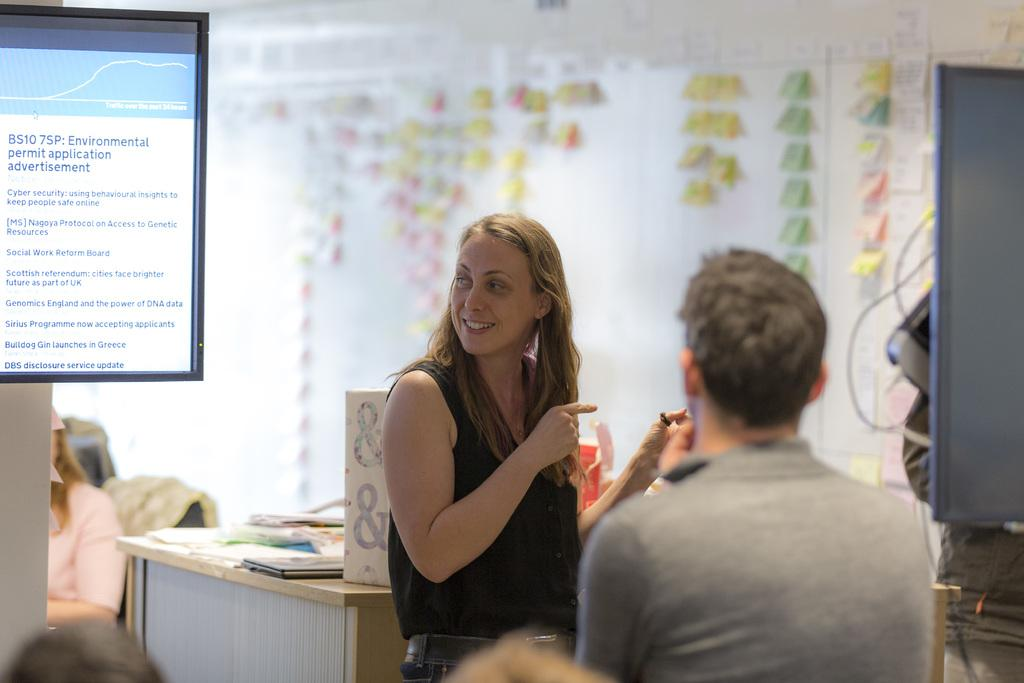What is the woman in the image wearing? The woman is wearing a black dress in the image. What is the woman doing in the image? The woman is standing in the image. Who is in front of the woman in the image? There are people in front of the woman in the image. What can be seen on either side of the woman? There are televisions on either side of the woman in the image. What type of pancake is the woman holding in the image? There is no pancake present in the image; the woman is wearing a black dress and standing with people in front of her. 